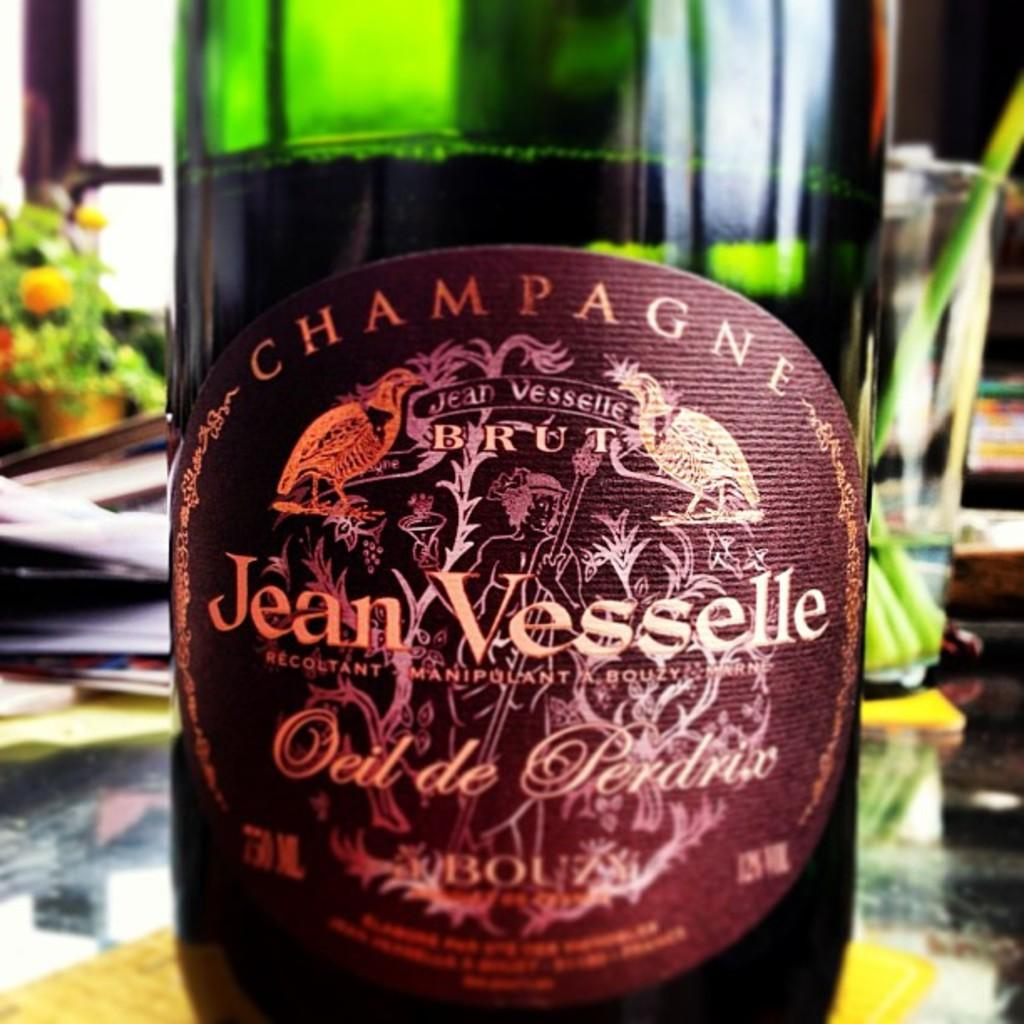<image>
Relay a brief, clear account of the picture shown. Bottle of alcohol with a label which says "Jean Vesselle" on it. 